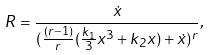Convert formula to latex. <formula><loc_0><loc_0><loc_500><loc_500>R = \frac { \dot { x } } { ( \frac { ( r - 1 ) } { r } ( \frac { k _ { 1 } } { 3 } x ^ { 3 } + k _ { 2 } x ) + \dot { x } ) ^ { r } } ,</formula> 